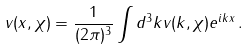Convert formula to latex. <formula><loc_0><loc_0><loc_500><loc_500>v ( x , \chi ) = \frac { 1 } { ( 2 \pi ) ^ { 3 } } \int d ^ { 3 } k v ( k , \chi ) e ^ { i k x } \, .</formula> 